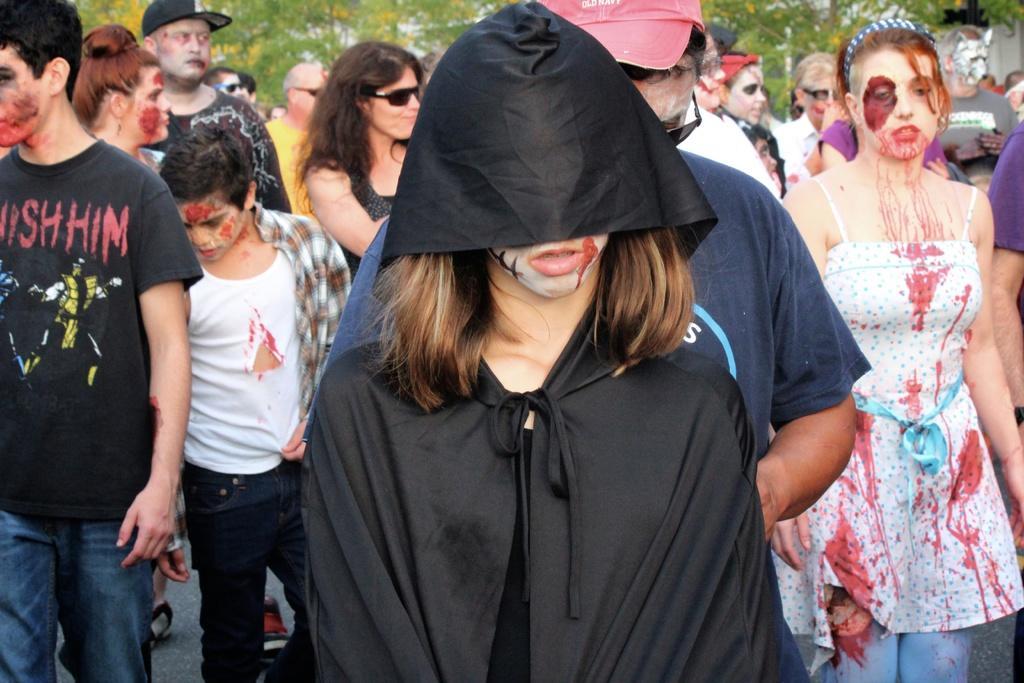In one or two sentences, can you explain what this image depicts? In this picture there are few persons standing and wearing fancy dress and there are trees in the background. 